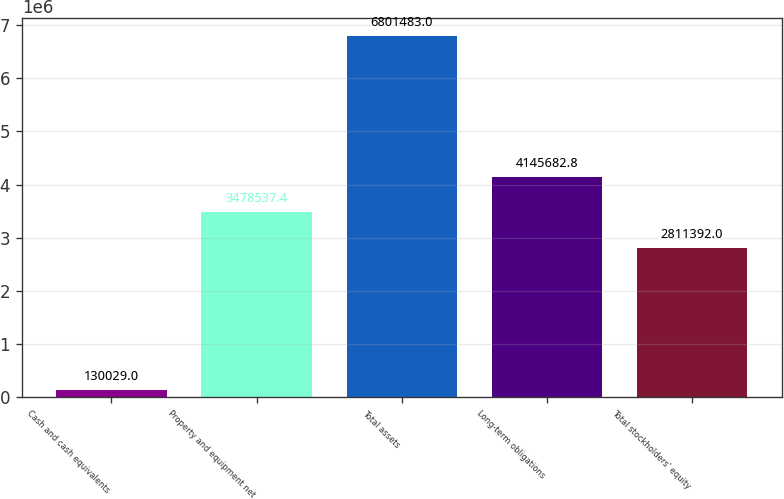Convert chart to OTSL. <chart><loc_0><loc_0><loc_500><loc_500><bar_chart><fcel>Cash and cash equivalents<fcel>Property and equipment net<fcel>Total assets<fcel>Long-term obligations<fcel>Total stockholders' equity<nl><fcel>130029<fcel>3.47854e+06<fcel>6.80148e+06<fcel>4.14568e+06<fcel>2.81139e+06<nl></chart> 